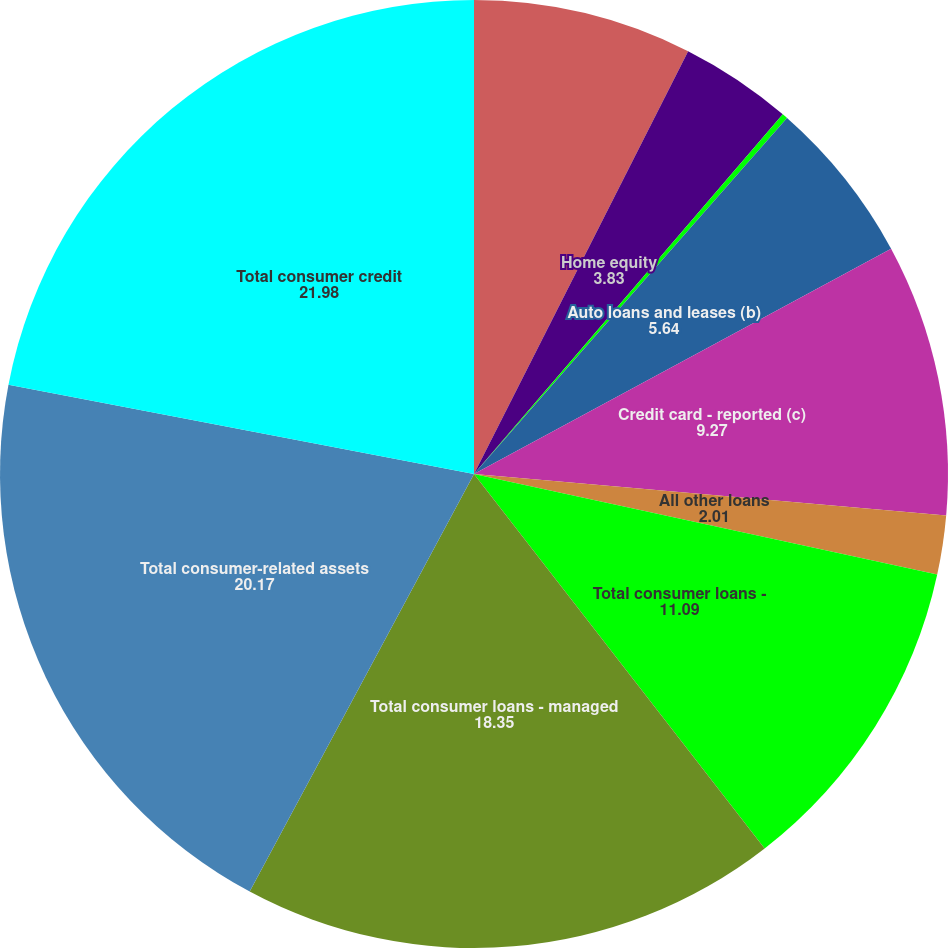<chart> <loc_0><loc_0><loc_500><loc_500><pie_chart><fcel>(in millions except ratios)<fcel>Home equity<fcel>Mortgage<fcel>Auto loans and leases (b)<fcel>Credit card - reported (c)<fcel>All other loans<fcel>Total consumer loans -<fcel>Total consumer loans - managed<fcel>Total consumer-related assets<fcel>Total consumer credit<nl><fcel>7.46%<fcel>3.83%<fcel>0.19%<fcel>5.64%<fcel>9.27%<fcel>2.01%<fcel>11.09%<fcel>18.35%<fcel>20.17%<fcel>21.98%<nl></chart> 